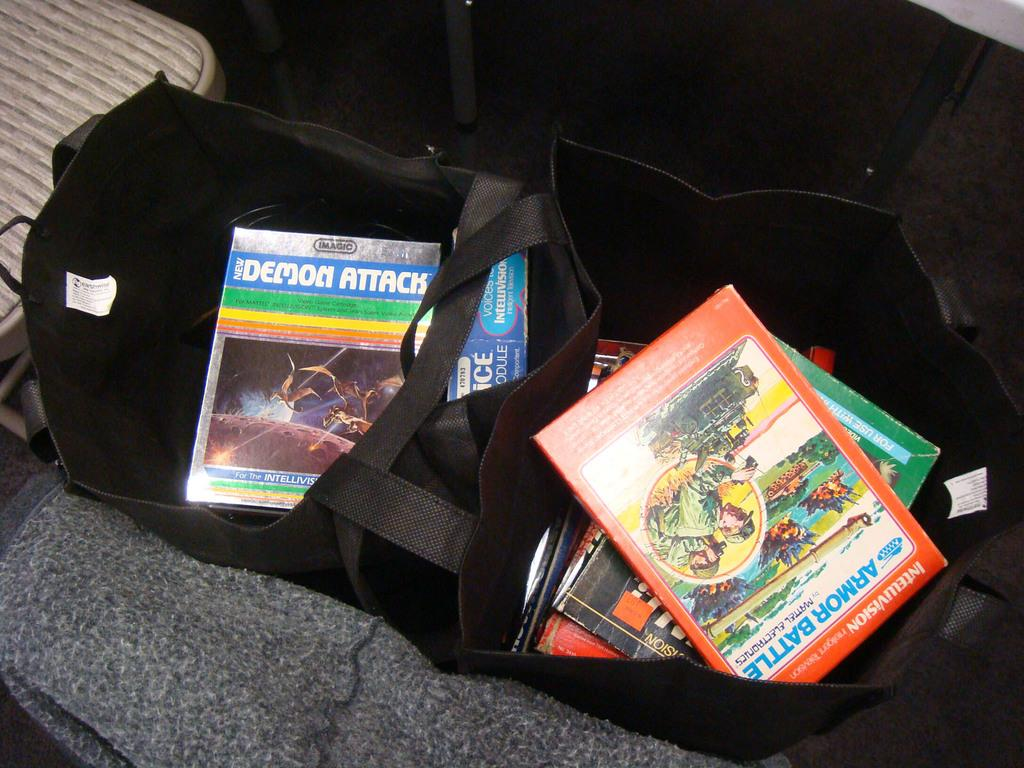<image>
Present a compact description of the photo's key features. Boxes of video games include ones for the Intellivision game system. 